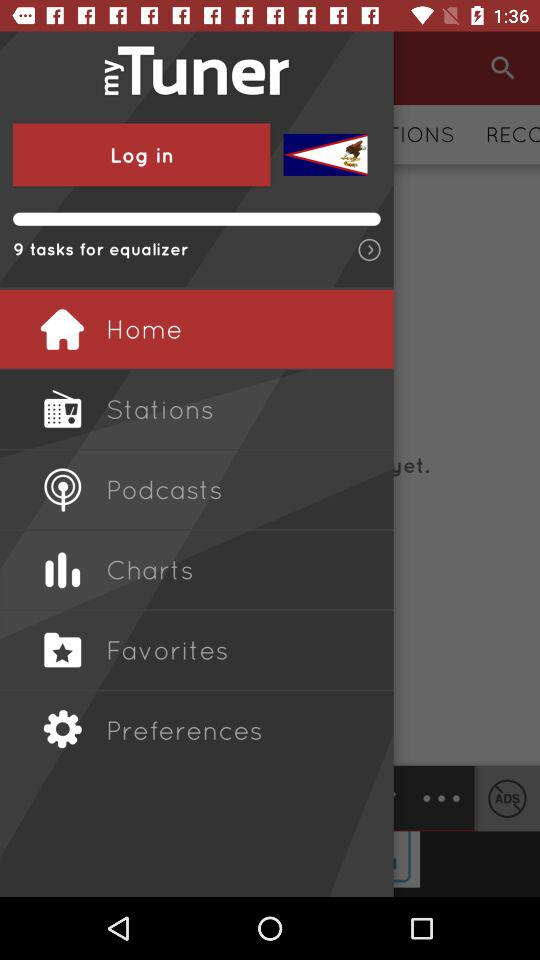What is the name of the radio station?
When the provided information is insufficient, respond with <no answer>. <no answer> 